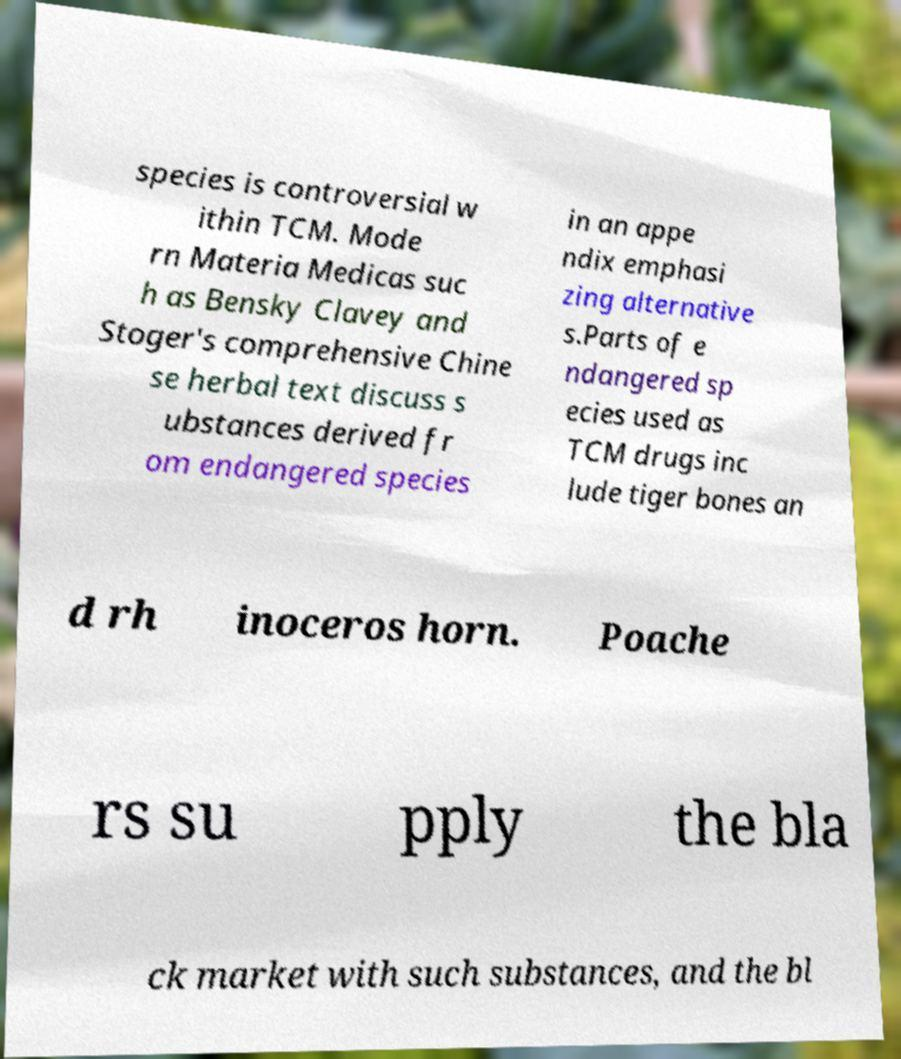Please read and relay the text visible in this image. What does it say? species is controversial w ithin TCM. Mode rn Materia Medicas suc h as Bensky Clavey and Stoger's comprehensive Chine se herbal text discuss s ubstances derived fr om endangered species in an appe ndix emphasi zing alternative s.Parts of e ndangered sp ecies used as TCM drugs inc lude tiger bones an d rh inoceros horn. Poache rs su pply the bla ck market with such substances, and the bl 